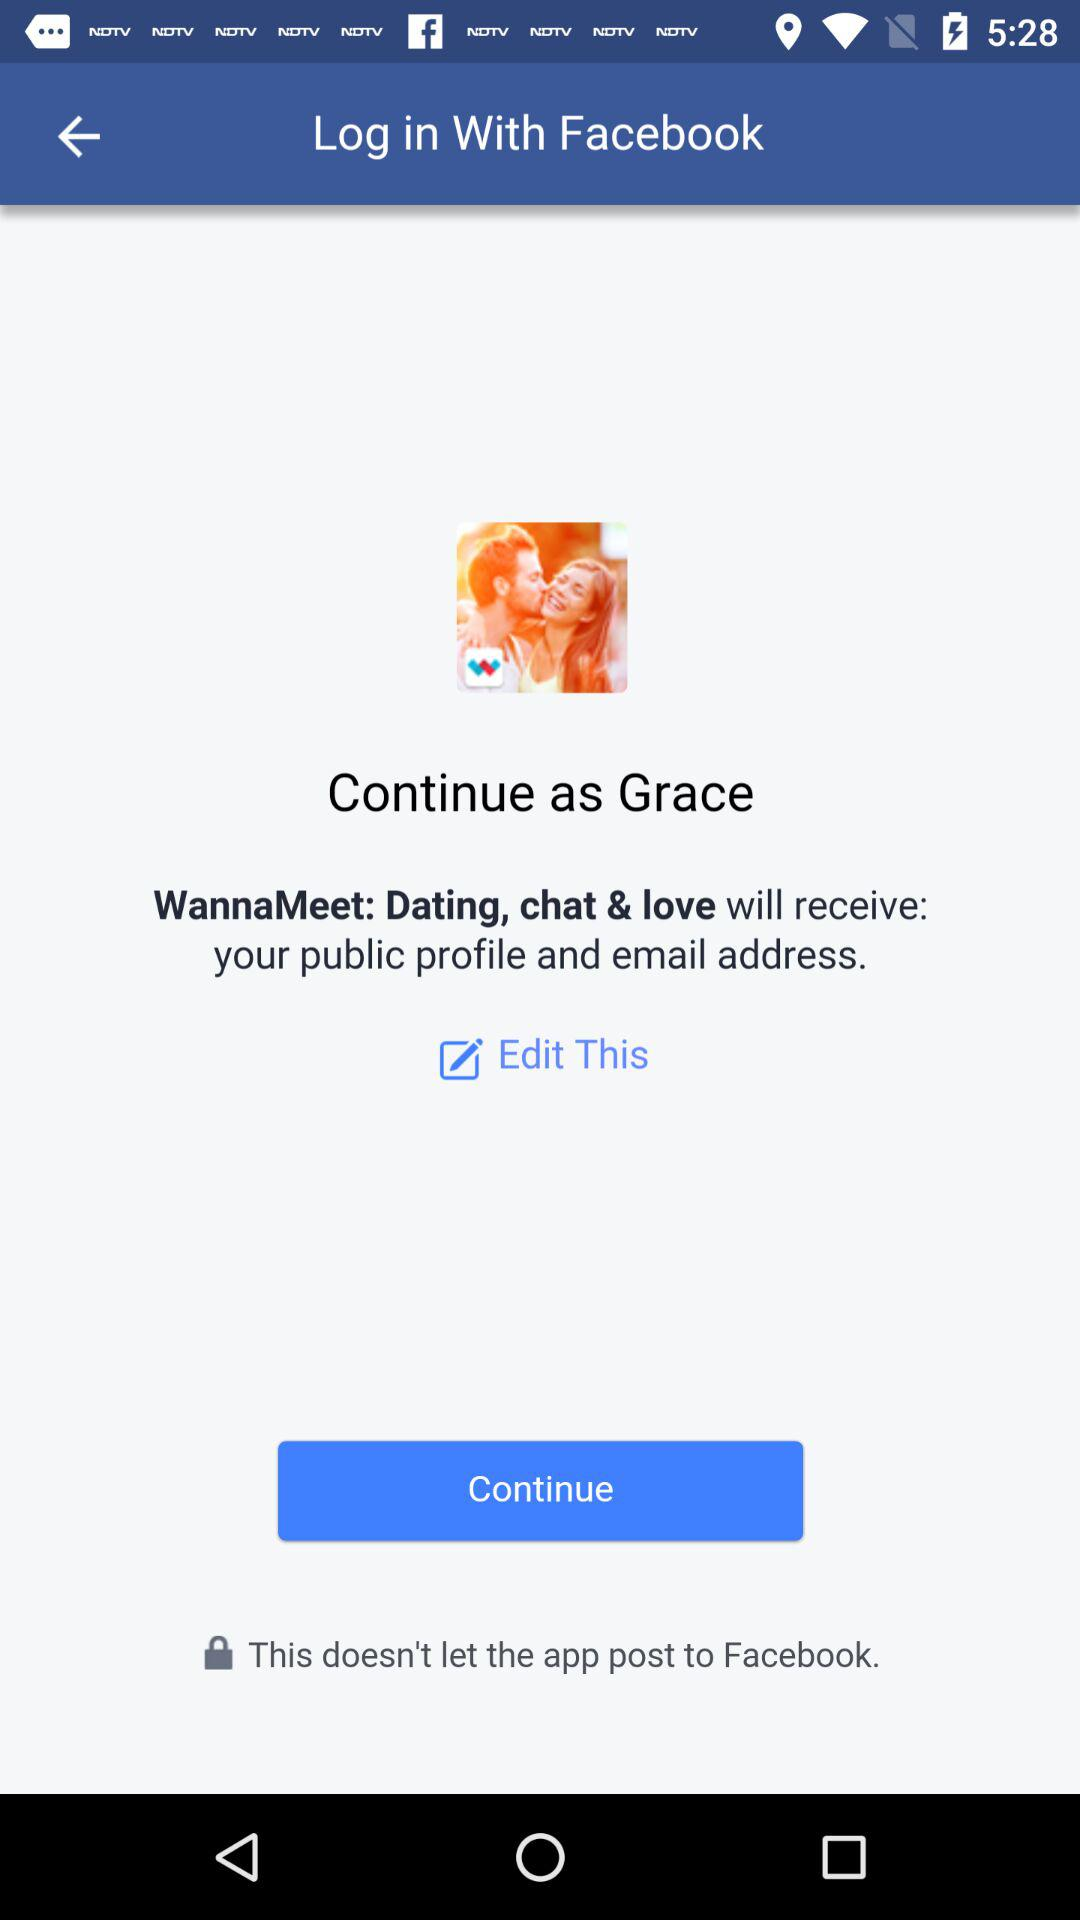What is the website to access?
When the provided information is insufficient, respond with <no answer>. <no answer> 